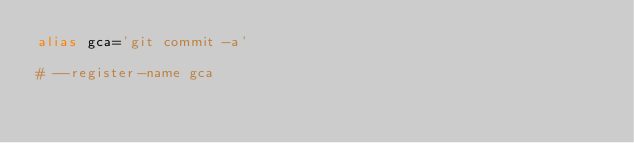Convert code to text. <code><loc_0><loc_0><loc_500><loc_500><_Bash_>alias gca='git commit -a'

# --register-name gca</code> 